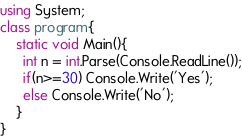<code> <loc_0><loc_0><loc_500><loc_500><_C#_>using System;
class program{
	static void Main(){
      int n = int.Parse(Console.ReadLine());
      if(n>=30) Console.Write('Yes');
      else Console.Write('No');
	}
}</code> 